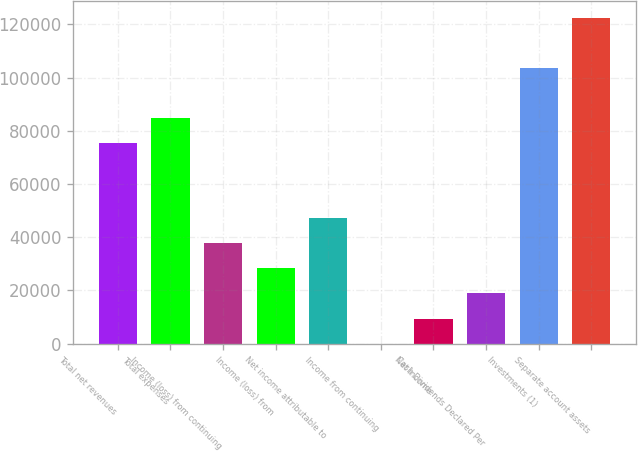Convert chart. <chart><loc_0><loc_0><loc_500><loc_500><bar_chart><fcel>Total net revenues<fcel>Total expenses<fcel>Income (loss) from continuing<fcel>Income (loss) from<fcel>Net income attributable to<fcel>Income from continuing<fcel>Net income<fcel>Cash Dividends Declared Per<fcel>Investments (1)<fcel>Separate account assets<nl><fcel>75438.5<fcel>84868.2<fcel>37719.3<fcel>28289.5<fcel>47149.1<fcel>0.14<fcel>9429.93<fcel>18859.7<fcel>103728<fcel>122587<nl></chart> 